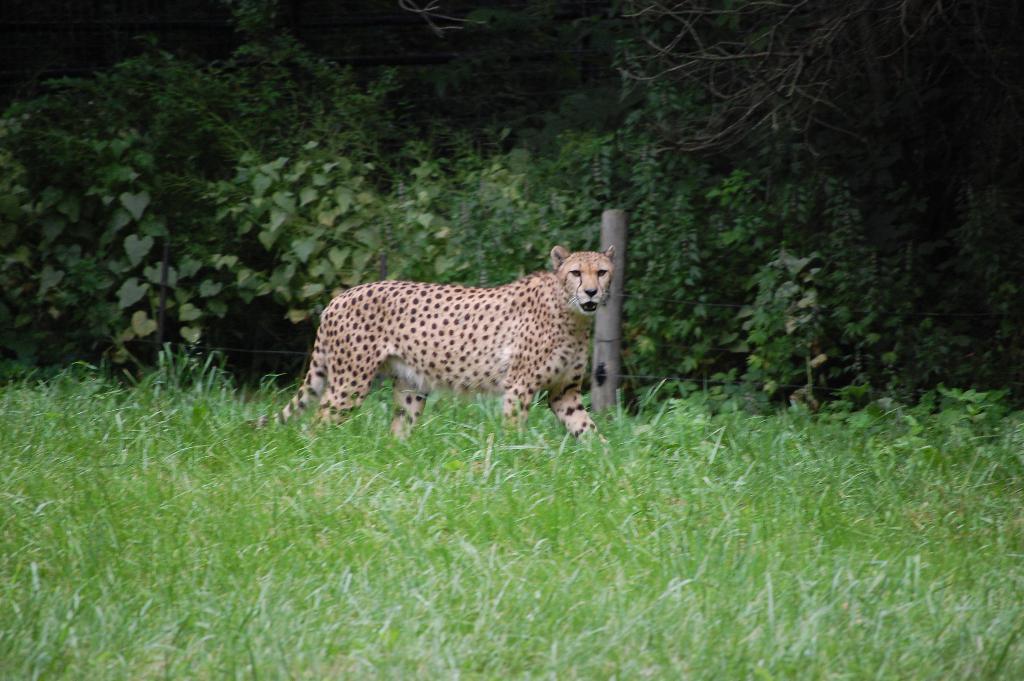Please provide a concise description of this image. In this picture we can see cheetah in the grass. There are few green plants in the background. 